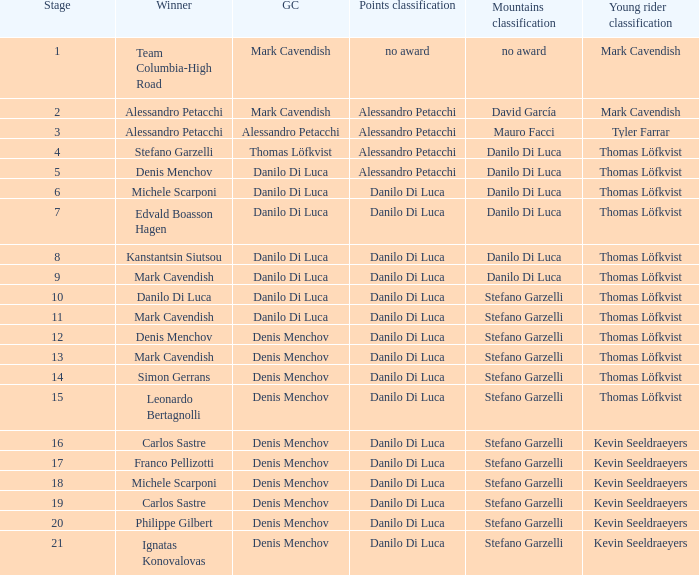When philippe gilbert is the winner who is the points classification? Danilo Di Luca. 